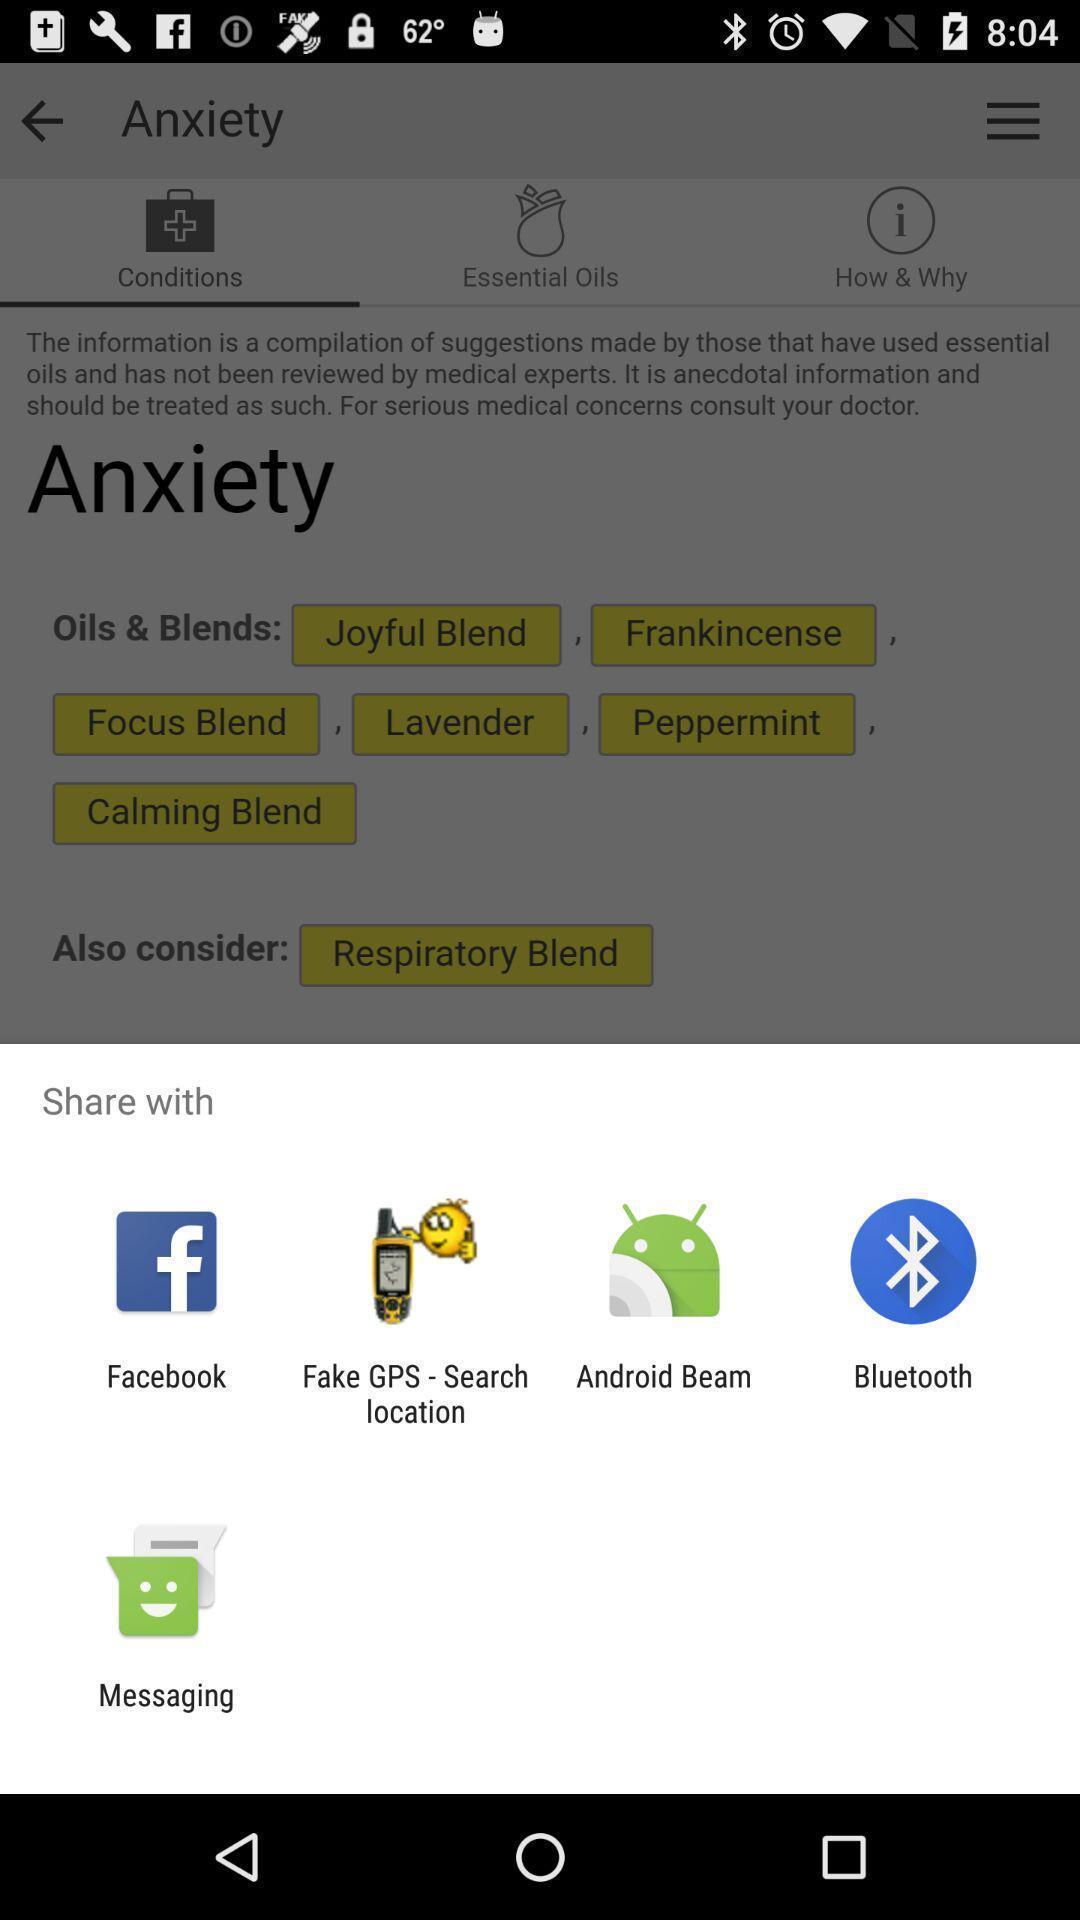Tell me what you see in this picture. Pop up showing various apps. 